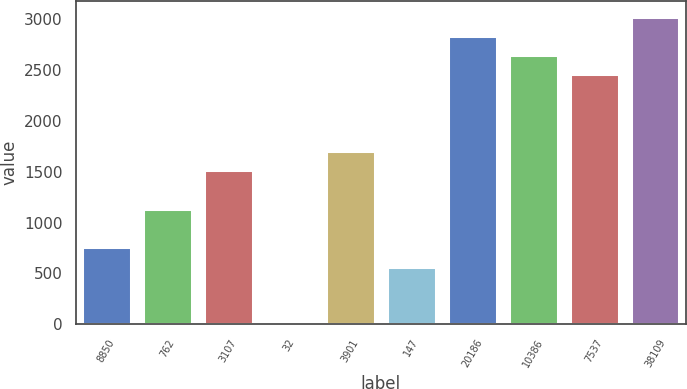<chart> <loc_0><loc_0><loc_500><loc_500><bar_chart><fcel>8850<fcel>762<fcel>3107<fcel>32<fcel>3901<fcel>147<fcel>20186<fcel>10386<fcel>7537<fcel>38109<nl><fcel>757.3<fcel>1135.6<fcel>1513.9<fcel>0.7<fcel>1703.05<fcel>568.15<fcel>2837.95<fcel>2648.8<fcel>2459.65<fcel>3027.1<nl></chart> 